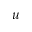<formula> <loc_0><loc_0><loc_500><loc_500>u</formula> 